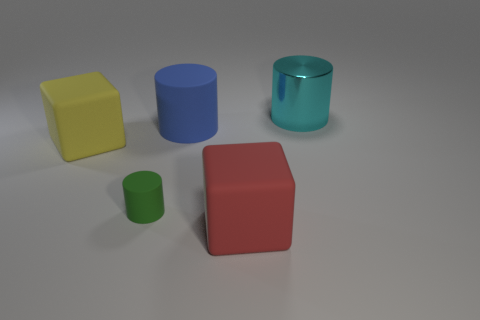What is the material of the cyan cylinder that is the same size as the blue rubber object?
Your answer should be compact. Metal. Are there any other things that have the same size as the green matte thing?
Ensure brevity in your answer.  No. How many objects are either large yellow rubber objects or rubber things behind the red cube?
Provide a short and direct response. 3. There is a blue cylinder that is the same material as the red block; what is its size?
Keep it short and to the point. Large. What is the shape of the large rubber thing in front of the large object on the left side of the tiny green matte object?
Your answer should be compact. Cube. There is a matte thing that is right of the yellow object and on the left side of the big blue thing; what size is it?
Offer a terse response. Small. Are there any large yellow matte objects that have the same shape as the red matte object?
Your answer should be very brief. Yes. What material is the big cylinder on the left side of the large cyan metal object to the right of the big yellow matte thing that is on the left side of the tiny green matte cylinder?
Keep it short and to the point. Rubber. Is there a blue matte cylinder of the same size as the blue object?
Provide a succinct answer. No. What is the color of the big cylinder in front of the large cyan metallic object that is on the right side of the large red matte object?
Provide a succinct answer. Blue. 